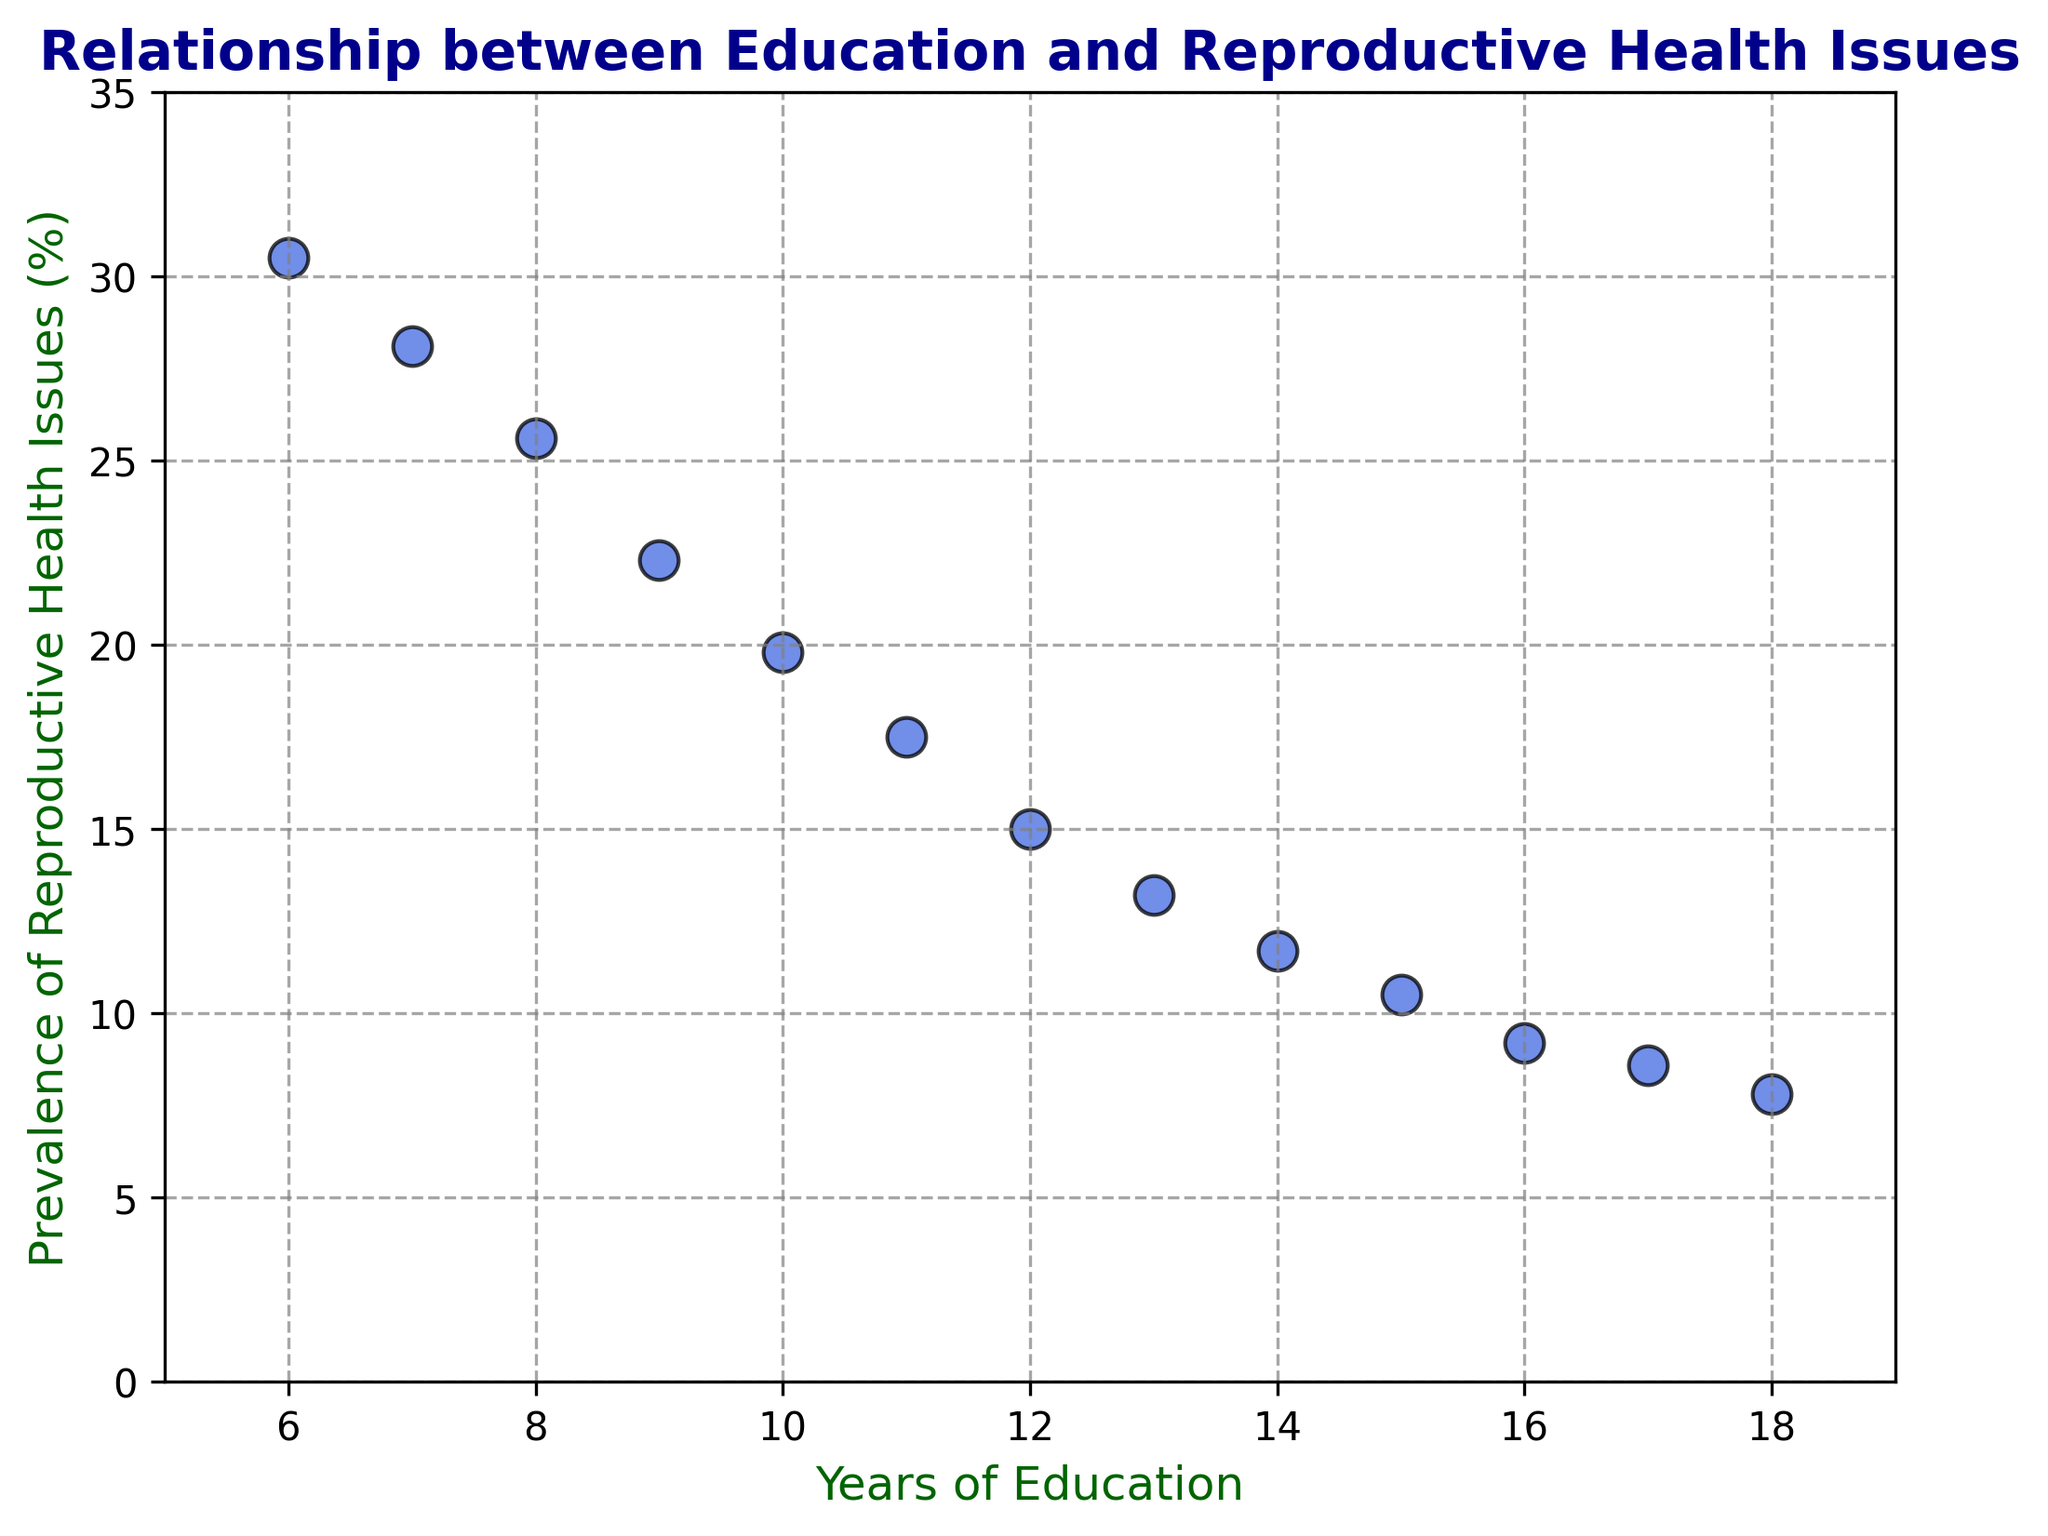What's the relationship between years of education and prevalence of reproductive health issues? The plot shows a downward trend where an increase in years of education corresponds to a decrease in the prevalence of reproductive health issues. This negative correlation suggests that women with more years of education tend to have fewer reproductive health issues.
Answer: Negative correlation What is the prevalence of reproductive health issues for women with 12 years of education? Locate 12 on the x-axis (Years of Education) and find the corresponding point on the y-axis that indicates the prevalence of reproductive health issues. The value is 15.0%.
Answer: 15.0% Which group has the lowest prevalence of reproductive health issues? Identify the data point with the smallest y-value on the scatter plot. The data point with 18 years of education has the lowest prevalence of reproductive health issues at 7.8%.
Answer: 18 years of education How does the prevalence of reproductive health issues compare between women with 10 years of education and women with 16 years of education? Find the points for 10 years and 16 years of education on the x-axis and compare their respective y-values. Women with 10 years of education have a prevalence of 19.8%, while those with 16 years have a prevalence of 9.2%. 10 years have a higher prevalence.
Answer: Higher for 10 years What is the range of prevalence rates observed in the plot? Determine the maximum and minimum y-values from the plot. The highest prevalence is 30.5%, and the lowest is 7.8%. The range is 30.5% - 7.8%.
Answer: 22.7% What is the difference in the prevalence of reproductive health issues between women with 8 years and 14 years of education? Find the y-values for 8 years (25.6%) and 14 years (11.7%). Subtract 11.7% from 25.6% to get the difference.
Answer: 13.9% Is the decrease in prevalence uniform across all years of education? By observing the scatter plot, note if the distance between points on the y-axis varies. The plot shows a gradual decrease, but the rate of decrease isn't strictly uniform across all years. Some intervals show more significant drops than others.
Answer: No What is the prevalence rate for women with the median value of years of education? Find the middle value in the sorted list of education years (which is 12 years). Locate the corresponding prevalence on the plot, which is 15.0%.
Answer: 15.0% What can be inferred about the overall trend from 6 years to 18 years of education? The overall trend is a consistent decrease in the prevalence of reproductive health issues as the years of education increase. This indicates that more education may be linked with better reproductive health outcomes.
Answer: Consistent decrease 